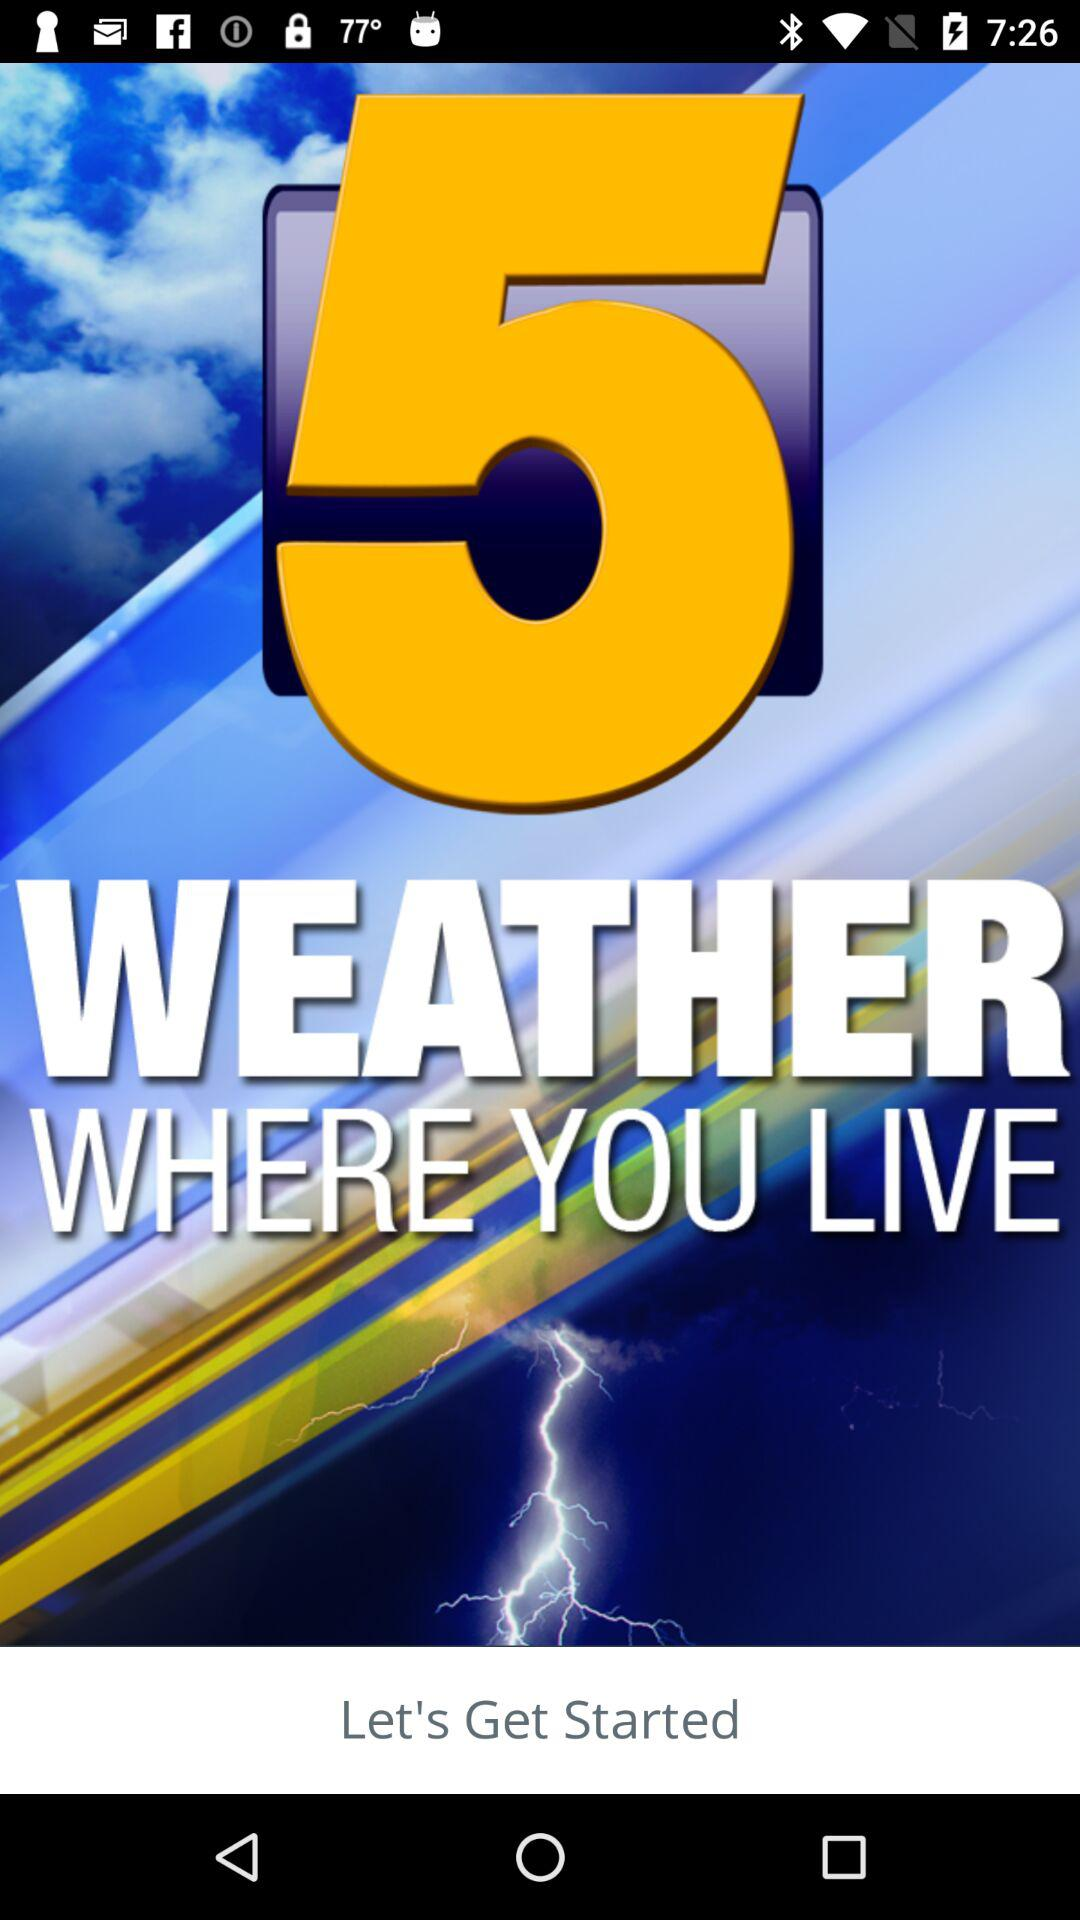What is the application name?
When the provided information is insufficient, respond with <no answer>. <no answer> 